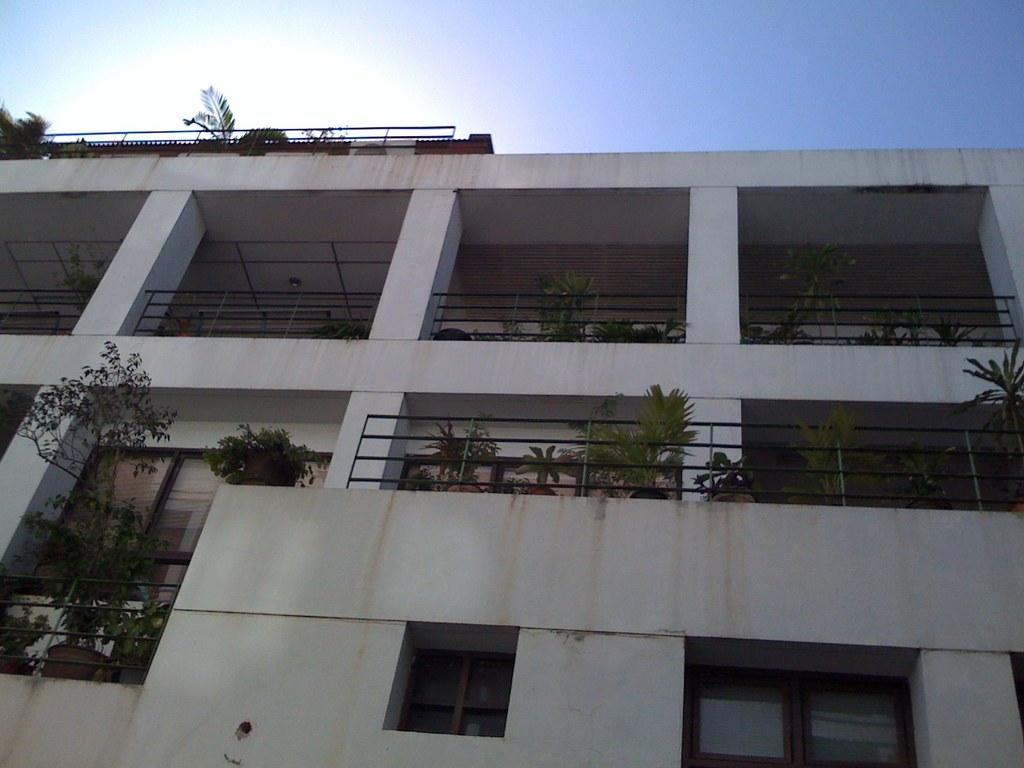How would you summarize this image in a sentence or two? In this image in the center there is a building which is white in colour and there are plants on the balcony of the building. On the top of the building there are plants. 